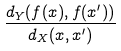Convert formula to latex. <formula><loc_0><loc_0><loc_500><loc_500>\frac { d _ { Y } ( f ( x ) , f ( x ^ { \prime } ) ) } { d _ { X } ( x , x ^ { \prime } ) }</formula> 